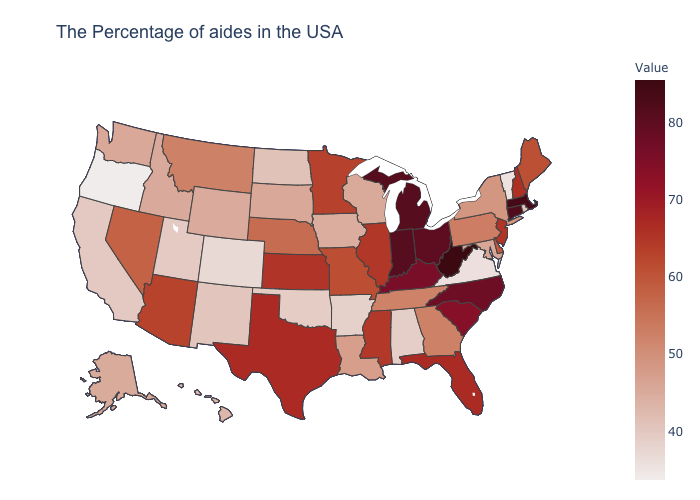Which states have the lowest value in the Northeast?
Quick response, please. Vermont. Does Arkansas have the highest value in the South?
Answer briefly. No. Among the states that border Texas , does Louisiana have the highest value?
Write a very short answer. Yes. Among the states that border Nevada , does Utah have the highest value?
Give a very brief answer. No. Which states hav the highest value in the MidWest?
Write a very short answer. Michigan, Indiana. Does Indiana have the highest value in the MidWest?
Short answer required. Yes. 